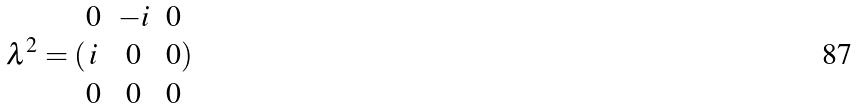Convert formula to latex. <formula><loc_0><loc_0><loc_500><loc_500>\lambda ^ { 2 } = ( \begin{matrix} 0 & - i & 0 \\ i & 0 & 0 \\ 0 & 0 & 0 \end{matrix} )</formula> 